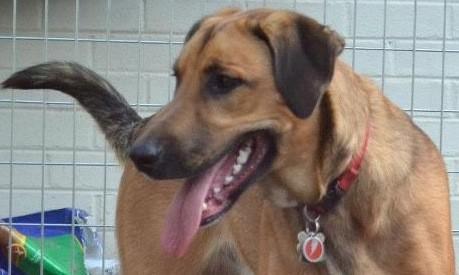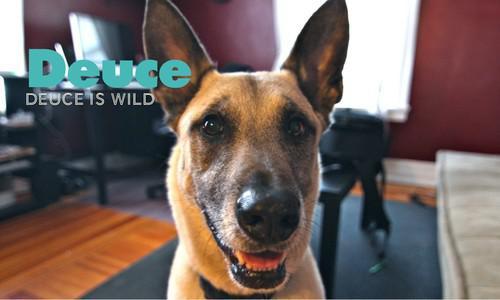The first image is the image on the left, the second image is the image on the right. Assess this claim about the two images: "Left image contains one tan adult dog wearing a collar.". Correct or not? Answer yes or no. Yes. The first image is the image on the left, the second image is the image on the right. Assess this claim about the two images: "There are more visible collars than dogs.". Correct or not? Answer yes or no. No. 